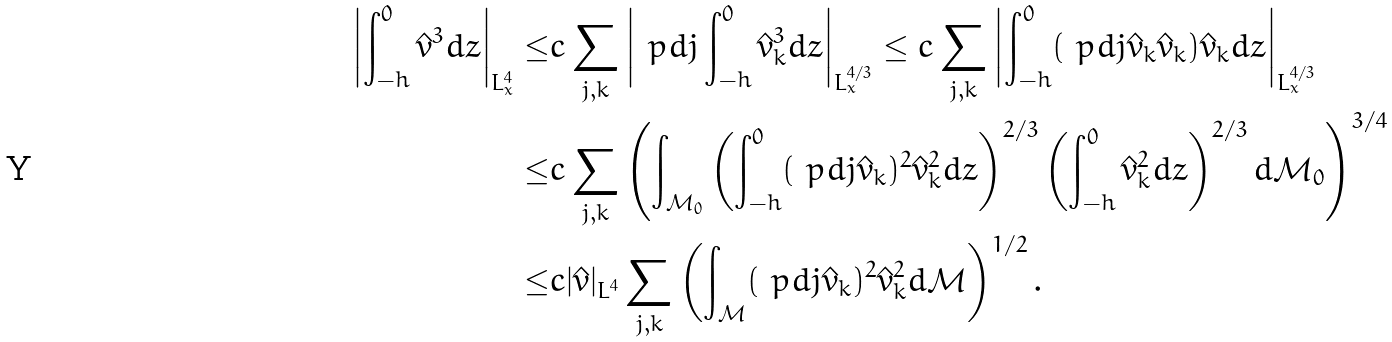<formula> <loc_0><loc_0><loc_500><loc_500>\left | \int _ { - h } ^ { 0 } \hat { v } ^ { 3 } d z \right | _ { L ^ { 4 } _ { x } } \leq & c \sum _ { j , k } \left | \ p d { j } \int _ { - h } ^ { 0 } \hat { v } ^ { 3 } _ { k } d z \right | _ { L ^ { 4 / 3 } _ { x } } \leq c \sum _ { j , k } \left | \int _ { - h } ^ { 0 } ( \ p d { j } \hat { v } _ { k } \hat { v } _ { k } ) \hat { v } _ { k } d z \right | _ { L ^ { 4 / 3 } _ { x } } \\ \leq & c \sum _ { j , k } \left ( \int _ { \mathcal { M } _ { 0 } } \left ( \int _ { - h } ^ { 0 } ( \ p d { j } \hat { v } _ { k } ) ^ { 2 } \hat { v } ^ { 2 } _ { k } d z \right ) ^ { 2 / 3 } \left ( \int _ { - h } ^ { 0 } \hat { v } ^ { 2 } _ { k } d z \right ) ^ { 2 / 3 } d \mathcal { M } _ { 0 } \right ) ^ { 3 / 4 } \\ \leq & c | \hat { v } | _ { L ^ { 4 } } \sum _ { j , k } \left ( \int _ { \mathcal { M } } ( \ p d { j } \hat { v } _ { k } ) ^ { 2 } \hat { v } ^ { 2 } _ { k } d \mathcal { M } \right ) ^ { 1 / 2 } . \\</formula> 